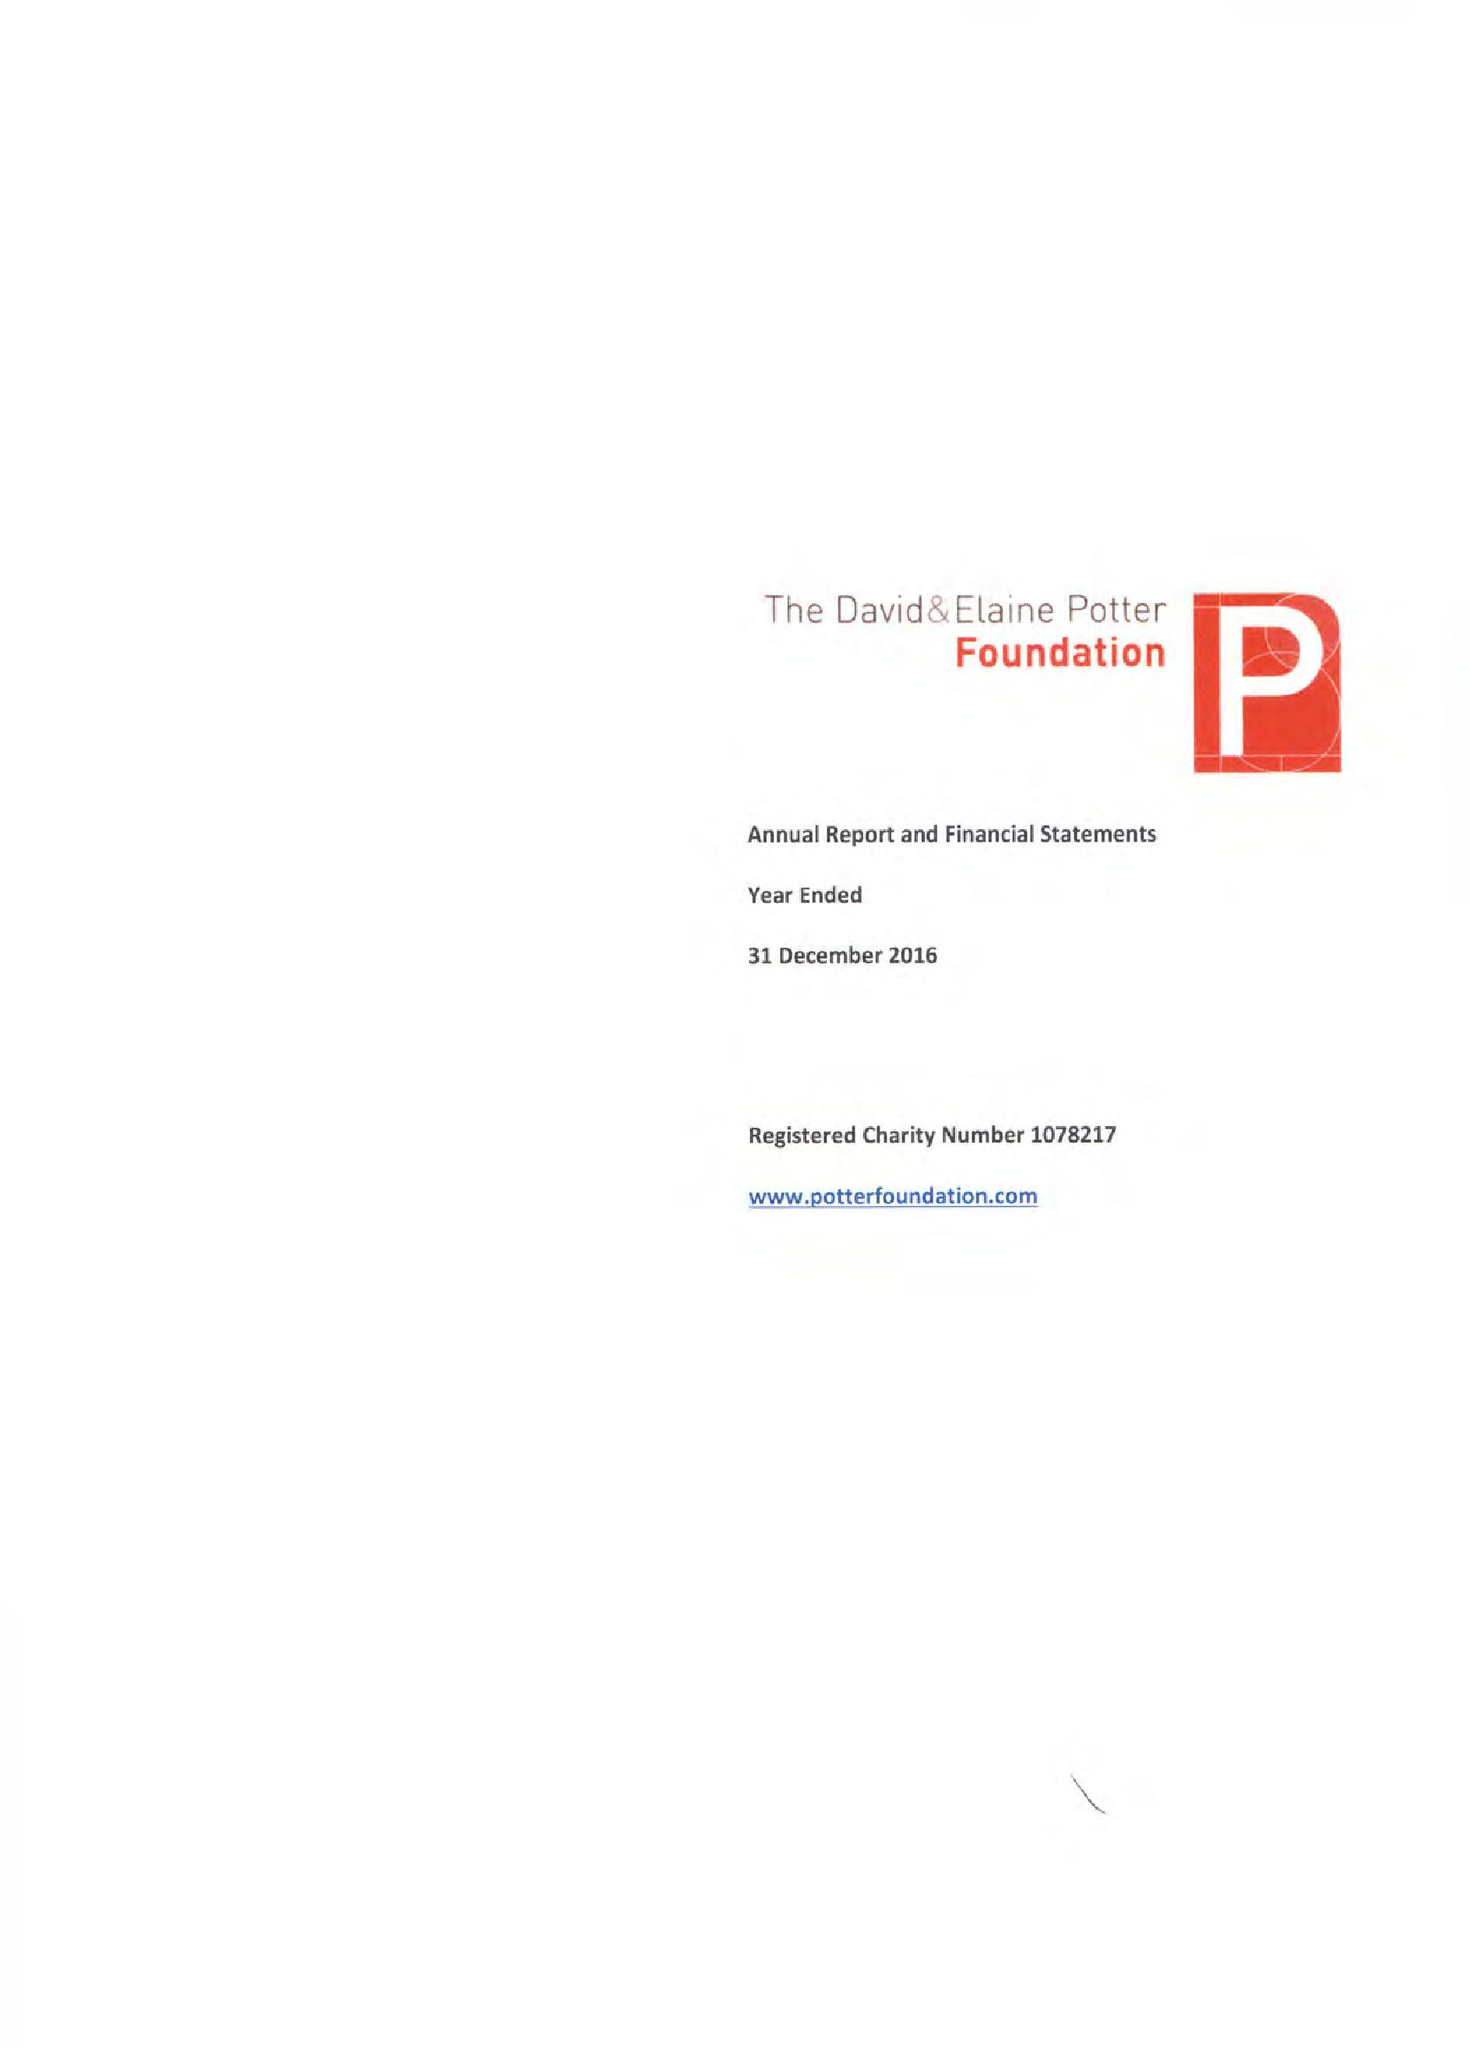What is the value for the spending_annually_in_british_pounds?
Answer the question using a single word or phrase. 1061820.00 